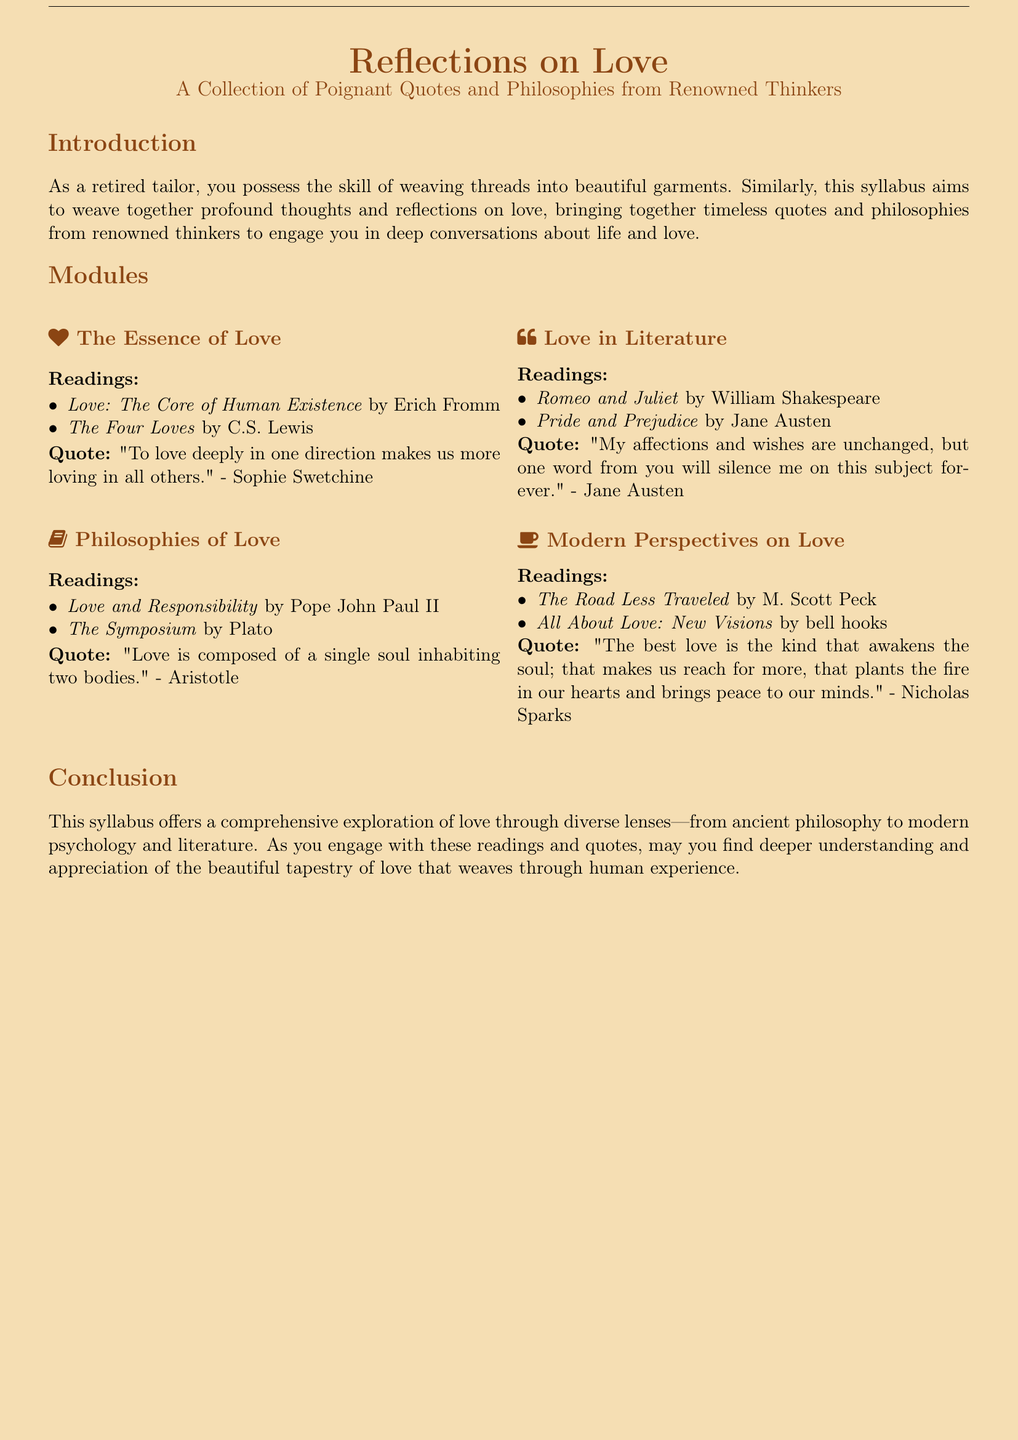What is the title of the syllabus? The title of the syllabus is presented at the top of the document.
Answer: Reflections on Love Who wrote "Love: The Core of Human Existence"? This book is listed under the first module about the essence of love.
Answer: Erich Fromm What quote is attributed to Sophie Swetchine? This quote is found in the section regarding the essence of love.
Answer: "To love deeply in one direction makes us more loving in all others." Which philosopher's work is included in the "Philosophies of Love" module? The syllabus lists philosophers and their works in the second module.
Answer: Aristotle What are the two literary works mentioned under the "Love in Literature" module? The module includes notable works that reflect on love.
Answer: Romeo and Juliet, Pride and Prejudice How many modules are included in the syllabus? The document outlines the structure of the syllabus in a list format.
Answer: Four What is the focus of the last module in the syllabus? The last module highlights contemporary perspectives on love.
Answer: Modern Perspectives on Love Who are the authors of the readings listed in the "Modern Perspectives on Love" module? The module specifically mentions two authors for contemporary readings.
Answer: M. Scott Peck, bell hooks 